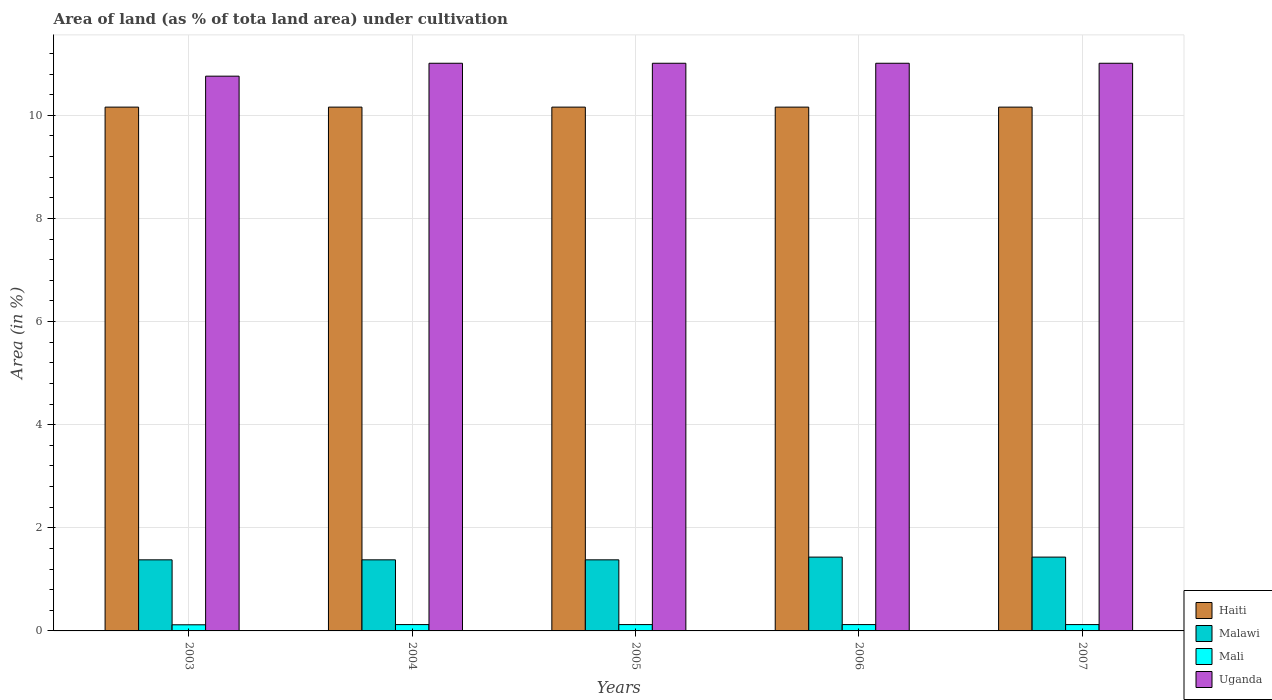Are the number of bars per tick equal to the number of legend labels?
Provide a short and direct response. Yes. How many bars are there on the 3rd tick from the left?
Offer a very short reply. 4. How many bars are there on the 5th tick from the right?
Offer a very short reply. 4. In how many cases, is the number of bars for a given year not equal to the number of legend labels?
Provide a succinct answer. 0. What is the percentage of land under cultivation in Malawi in 2005?
Give a very brief answer. 1.38. Across all years, what is the maximum percentage of land under cultivation in Uganda?
Your answer should be very brief. 11.01. Across all years, what is the minimum percentage of land under cultivation in Uganda?
Keep it short and to the point. 10.76. What is the total percentage of land under cultivation in Malawi in the graph?
Your answer should be compact. 7. What is the difference between the percentage of land under cultivation in Malawi in 2004 and that in 2007?
Keep it short and to the point. -0.05. What is the difference between the percentage of land under cultivation in Uganda in 2006 and the percentage of land under cultivation in Mali in 2004?
Offer a terse response. 10.89. What is the average percentage of land under cultivation in Mali per year?
Ensure brevity in your answer.  0.12. In the year 2004, what is the difference between the percentage of land under cultivation in Mali and percentage of land under cultivation in Haiti?
Your response must be concise. -10.04. In how many years, is the percentage of land under cultivation in Mali greater than 4.4 %?
Your answer should be compact. 0. What is the difference between the highest and the lowest percentage of land under cultivation in Uganda?
Keep it short and to the point. 0.25. What does the 1st bar from the left in 2004 represents?
Your response must be concise. Haiti. What does the 4th bar from the right in 2006 represents?
Your answer should be very brief. Haiti. Is it the case that in every year, the sum of the percentage of land under cultivation in Mali and percentage of land under cultivation in Haiti is greater than the percentage of land under cultivation in Malawi?
Your answer should be compact. Yes. How many bars are there?
Provide a succinct answer. 20. Are all the bars in the graph horizontal?
Your response must be concise. No. Are the values on the major ticks of Y-axis written in scientific E-notation?
Make the answer very short. No. How many legend labels are there?
Provide a short and direct response. 4. How are the legend labels stacked?
Make the answer very short. Vertical. What is the title of the graph?
Your answer should be compact. Area of land (as % of tota land area) under cultivation. Does "Trinidad and Tobago" appear as one of the legend labels in the graph?
Give a very brief answer. No. What is the label or title of the X-axis?
Provide a succinct answer. Years. What is the label or title of the Y-axis?
Keep it short and to the point. Area (in %). What is the Area (in %) in Haiti in 2003?
Provide a succinct answer. 10.16. What is the Area (in %) of Malawi in 2003?
Keep it short and to the point. 1.38. What is the Area (in %) in Mali in 2003?
Provide a short and direct response. 0.12. What is the Area (in %) in Uganda in 2003?
Provide a succinct answer. 10.76. What is the Area (in %) in Haiti in 2004?
Offer a very short reply. 10.16. What is the Area (in %) of Malawi in 2004?
Provide a short and direct response. 1.38. What is the Area (in %) of Mali in 2004?
Ensure brevity in your answer.  0.12. What is the Area (in %) in Uganda in 2004?
Keep it short and to the point. 11.01. What is the Area (in %) of Haiti in 2005?
Offer a very short reply. 10.16. What is the Area (in %) of Malawi in 2005?
Keep it short and to the point. 1.38. What is the Area (in %) of Mali in 2005?
Offer a very short reply. 0.12. What is the Area (in %) of Uganda in 2005?
Ensure brevity in your answer.  11.01. What is the Area (in %) in Haiti in 2006?
Give a very brief answer. 10.16. What is the Area (in %) of Malawi in 2006?
Your response must be concise. 1.43. What is the Area (in %) in Mali in 2006?
Provide a succinct answer. 0.12. What is the Area (in %) of Uganda in 2006?
Your answer should be very brief. 11.01. What is the Area (in %) of Haiti in 2007?
Your answer should be very brief. 10.16. What is the Area (in %) of Malawi in 2007?
Offer a very short reply. 1.43. What is the Area (in %) in Mali in 2007?
Offer a very short reply. 0.12. What is the Area (in %) of Uganda in 2007?
Your answer should be very brief. 11.01. Across all years, what is the maximum Area (in %) in Haiti?
Provide a short and direct response. 10.16. Across all years, what is the maximum Area (in %) of Malawi?
Your answer should be very brief. 1.43. Across all years, what is the maximum Area (in %) in Mali?
Give a very brief answer. 0.12. Across all years, what is the maximum Area (in %) in Uganda?
Provide a succinct answer. 11.01. Across all years, what is the minimum Area (in %) in Haiti?
Give a very brief answer. 10.16. Across all years, what is the minimum Area (in %) in Malawi?
Keep it short and to the point. 1.38. Across all years, what is the minimum Area (in %) in Mali?
Your answer should be very brief. 0.12. Across all years, what is the minimum Area (in %) of Uganda?
Offer a very short reply. 10.76. What is the total Area (in %) of Haiti in the graph?
Provide a succinct answer. 50.8. What is the total Area (in %) in Malawi in the graph?
Offer a terse response. 7. What is the total Area (in %) of Mali in the graph?
Keep it short and to the point. 0.61. What is the total Area (in %) in Uganda in the graph?
Provide a short and direct response. 54.8. What is the difference between the Area (in %) of Malawi in 2003 and that in 2004?
Offer a very short reply. 0. What is the difference between the Area (in %) of Mali in 2003 and that in 2004?
Your answer should be compact. -0. What is the difference between the Area (in %) in Uganda in 2003 and that in 2004?
Give a very brief answer. -0.25. What is the difference between the Area (in %) in Mali in 2003 and that in 2005?
Your answer should be very brief. -0. What is the difference between the Area (in %) of Uganda in 2003 and that in 2005?
Your answer should be very brief. -0.25. What is the difference between the Area (in %) in Malawi in 2003 and that in 2006?
Keep it short and to the point. -0.05. What is the difference between the Area (in %) in Mali in 2003 and that in 2006?
Offer a terse response. -0. What is the difference between the Area (in %) in Uganda in 2003 and that in 2006?
Offer a terse response. -0.25. What is the difference between the Area (in %) in Malawi in 2003 and that in 2007?
Your response must be concise. -0.05. What is the difference between the Area (in %) in Mali in 2003 and that in 2007?
Make the answer very short. -0. What is the difference between the Area (in %) in Uganda in 2003 and that in 2007?
Provide a succinct answer. -0.25. What is the difference between the Area (in %) of Haiti in 2004 and that in 2005?
Give a very brief answer. 0. What is the difference between the Area (in %) in Uganda in 2004 and that in 2005?
Give a very brief answer. 0. What is the difference between the Area (in %) of Malawi in 2004 and that in 2006?
Your answer should be very brief. -0.05. What is the difference between the Area (in %) in Mali in 2004 and that in 2006?
Your answer should be very brief. 0. What is the difference between the Area (in %) of Uganda in 2004 and that in 2006?
Provide a succinct answer. 0. What is the difference between the Area (in %) of Haiti in 2004 and that in 2007?
Your answer should be compact. 0. What is the difference between the Area (in %) of Malawi in 2004 and that in 2007?
Your answer should be very brief. -0.05. What is the difference between the Area (in %) of Haiti in 2005 and that in 2006?
Ensure brevity in your answer.  0. What is the difference between the Area (in %) in Malawi in 2005 and that in 2006?
Ensure brevity in your answer.  -0.05. What is the difference between the Area (in %) in Mali in 2005 and that in 2006?
Provide a short and direct response. 0. What is the difference between the Area (in %) in Haiti in 2005 and that in 2007?
Your response must be concise. 0. What is the difference between the Area (in %) of Malawi in 2005 and that in 2007?
Give a very brief answer. -0.05. What is the difference between the Area (in %) in Mali in 2005 and that in 2007?
Give a very brief answer. 0. What is the difference between the Area (in %) in Haiti in 2006 and that in 2007?
Ensure brevity in your answer.  0. What is the difference between the Area (in %) in Mali in 2006 and that in 2007?
Your answer should be very brief. 0. What is the difference between the Area (in %) in Uganda in 2006 and that in 2007?
Provide a succinct answer. 0. What is the difference between the Area (in %) in Haiti in 2003 and the Area (in %) in Malawi in 2004?
Your response must be concise. 8.78. What is the difference between the Area (in %) of Haiti in 2003 and the Area (in %) of Mali in 2004?
Your response must be concise. 10.04. What is the difference between the Area (in %) in Haiti in 2003 and the Area (in %) in Uganda in 2004?
Your answer should be compact. -0.85. What is the difference between the Area (in %) in Malawi in 2003 and the Area (in %) in Mali in 2004?
Your answer should be compact. 1.26. What is the difference between the Area (in %) in Malawi in 2003 and the Area (in %) in Uganda in 2004?
Ensure brevity in your answer.  -9.63. What is the difference between the Area (in %) in Mali in 2003 and the Area (in %) in Uganda in 2004?
Provide a succinct answer. -10.89. What is the difference between the Area (in %) in Haiti in 2003 and the Area (in %) in Malawi in 2005?
Offer a terse response. 8.78. What is the difference between the Area (in %) of Haiti in 2003 and the Area (in %) of Mali in 2005?
Your response must be concise. 10.04. What is the difference between the Area (in %) of Haiti in 2003 and the Area (in %) of Uganda in 2005?
Provide a succinct answer. -0.85. What is the difference between the Area (in %) of Malawi in 2003 and the Area (in %) of Mali in 2005?
Your answer should be very brief. 1.26. What is the difference between the Area (in %) in Malawi in 2003 and the Area (in %) in Uganda in 2005?
Provide a short and direct response. -9.63. What is the difference between the Area (in %) in Mali in 2003 and the Area (in %) in Uganda in 2005?
Provide a short and direct response. -10.89. What is the difference between the Area (in %) in Haiti in 2003 and the Area (in %) in Malawi in 2006?
Ensure brevity in your answer.  8.73. What is the difference between the Area (in %) of Haiti in 2003 and the Area (in %) of Mali in 2006?
Keep it short and to the point. 10.04. What is the difference between the Area (in %) of Haiti in 2003 and the Area (in %) of Uganda in 2006?
Make the answer very short. -0.85. What is the difference between the Area (in %) in Malawi in 2003 and the Area (in %) in Mali in 2006?
Provide a short and direct response. 1.26. What is the difference between the Area (in %) in Malawi in 2003 and the Area (in %) in Uganda in 2006?
Your answer should be compact. -9.63. What is the difference between the Area (in %) of Mali in 2003 and the Area (in %) of Uganda in 2006?
Offer a terse response. -10.89. What is the difference between the Area (in %) of Haiti in 2003 and the Area (in %) of Malawi in 2007?
Your answer should be compact. 8.73. What is the difference between the Area (in %) in Haiti in 2003 and the Area (in %) in Mali in 2007?
Provide a short and direct response. 10.04. What is the difference between the Area (in %) in Haiti in 2003 and the Area (in %) in Uganda in 2007?
Ensure brevity in your answer.  -0.85. What is the difference between the Area (in %) of Malawi in 2003 and the Area (in %) of Mali in 2007?
Give a very brief answer. 1.26. What is the difference between the Area (in %) of Malawi in 2003 and the Area (in %) of Uganda in 2007?
Your response must be concise. -9.63. What is the difference between the Area (in %) of Mali in 2003 and the Area (in %) of Uganda in 2007?
Provide a short and direct response. -10.89. What is the difference between the Area (in %) in Haiti in 2004 and the Area (in %) in Malawi in 2005?
Make the answer very short. 8.78. What is the difference between the Area (in %) of Haiti in 2004 and the Area (in %) of Mali in 2005?
Provide a succinct answer. 10.04. What is the difference between the Area (in %) in Haiti in 2004 and the Area (in %) in Uganda in 2005?
Ensure brevity in your answer.  -0.85. What is the difference between the Area (in %) of Malawi in 2004 and the Area (in %) of Mali in 2005?
Your answer should be very brief. 1.26. What is the difference between the Area (in %) of Malawi in 2004 and the Area (in %) of Uganda in 2005?
Keep it short and to the point. -9.63. What is the difference between the Area (in %) in Mali in 2004 and the Area (in %) in Uganda in 2005?
Offer a terse response. -10.89. What is the difference between the Area (in %) in Haiti in 2004 and the Area (in %) in Malawi in 2006?
Offer a terse response. 8.73. What is the difference between the Area (in %) in Haiti in 2004 and the Area (in %) in Mali in 2006?
Ensure brevity in your answer.  10.04. What is the difference between the Area (in %) of Haiti in 2004 and the Area (in %) of Uganda in 2006?
Your response must be concise. -0.85. What is the difference between the Area (in %) in Malawi in 2004 and the Area (in %) in Mali in 2006?
Offer a very short reply. 1.26. What is the difference between the Area (in %) of Malawi in 2004 and the Area (in %) of Uganda in 2006?
Make the answer very short. -9.63. What is the difference between the Area (in %) of Mali in 2004 and the Area (in %) of Uganda in 2006?
Give a very brief answer. -10.89. What is the difference between the Area (in %) in Haiti in 2004 and the Area (in %) in Malawi in 2007?
Give a very brief answer. 8.73. What is the difference between the Area (in %) in Haiti in 2004 and the Area (in %) in Mali in 2007?
Offer a very short reply. 10.04. What is the difference between the Area (in %) in Haiti in 2004 and the Area (in %) in Uganda in 2007?
Ensure brevity in your answer.  -0.85. What is the difference between the Area (in %) in Malawi in 2004 and the Area (in %) in Mali in 2007?
Offer a very short reply. 1.26. What is the difference between the Area (in %) of Malawi in 2004 and the Area (in %) of Uganda in 2007?
Keep it short and to the point. -9.63. What is the difference between the Area (in %) of Mali in 2004 and the Area (in %) of Uganda in 2007?
Make the answer very short. -10.89. What is the difference between the Area (in %) in Haiti in 2005 and the Area (in %) in Malawi in 2006?
Your response must be concise. 8.73. What is the difference between the Area (in %) in Haiti in 2005 and the Area (in %) in Mali in 2006?
Provide a succinct answer. 10.04. What is the difference between the Area (in %) of Haiti in 2005 and the Area (in %) of Uganda in 2006?
Offer a very short reply. -0.85. What is the difference between the Area (in %) in Malawi in 2005 and the Area (in %) in Mali in 2006?
Make the answer very short. 1.26. What is the difference between the Area (in %) in Malawi in 2005 and the Area (in %) in Uganda in 2006?
Offer a very short reply. -9.63. What is the difference between the Area (in %) of Mali in 2005 and the Area (in %) of Uganda in 2006?
Keep it short and to the point. -10.89. What is the difference between the Area (in %) of Haiti in 2005 and the Area (in %) of Malawi in 2007?
Offer a terse response. 8.73. What is the difference between the Area (in %) in Haiti in 2005 and the Area (in %) in Mali in 2007?
Provide a succinct answer. 10.04. What is the difference between the Area (in %) of Haiti in 2005 and the Area (in %) of Uganda in 2007?
Your answer should be compact. -0.85. What is the difference between the Area (in %) of Malawi in 2005 and the Area (in %) of Mali in 2007?
Give a very brief answer. 1.26. What is the difference between the Area (in %) of Malawi in 2005 and the Area (in %) of Uganda in 2007?
Your answer should be compact. -9.63. What is the difference between the Area (in %) in Mali in 2005 and the Area (in %) in Uganda in 2007?
Your answer should be very brief. -10.89. What is the difference between the Area (in %) in Haiti in 2006 and the Area (in %) in Malawi in 2007?
Offer a very short reply. 8.73. What is the difference between the Area (in %) of Haiti in 2006 and the Area (in %) of Mali in 2007?
Offer a terse response. 10.04. What is the difference between the Area (in %) of Haiti in 2006 and the Area (in %) of Uganda in 2007?
Provide a succinct answer. -0.85. What is the difference between the Area (in %) of Malawi in 2006 and the Area (in %) of Mali in 2007?
Provide a short and direct response. 1.31. What is the difference between the Area (in %) of Malawi in 2006 and the Area (in %) of Uganda in 2007?
Offer a very short reply. -9.58. What is the difference between the Area (in %) of Mali in 2006 and the Area (in %) of Uganda in 2007?
Your answer should be very brief. -10.89. What is the average Area (in %) of Haiti per year?
Make the answer very short. 10.16. What is the average Area (in %) in Malawi per year?
Your answer should be very brief. 1.4. What is the average Area (in %) in Mali per year?
Make the answer very short. 0.12. What is the average Area (in %) in Uganda per year?
Offer a very short reply. 10.96. In the year 2003, what is the difference between the Area (in %) in Haiti and Area (in %) in Malawi?
Give a very brief answer. 8.78. In the year 2003, what is the difference between the Area (in %) in Haiti and Area (in %) in Mali?
Provide a succinct answer. 10.04. In the year 2003, what is the difference between the Area (in %) in Haiti and Area (in %) in Uganda?
Make the answer very short. -0.6. In the year 2003, what is the difference between the Area (in %) of Malawi and Area (in %) of Mali?
Offer a very short reply. 1.26. In the year 2003, what is the difference between the Area (in %) in Malawi and Area (in %) in Uganda?
Your answer should be very brief. -9.38. In the year 2003, what is the difference between the Area (in %) in Mali and Area (in %) in Uganda?
Provide a short and direct response. -10.64. In the year 2004, what is the difference between the Area (in %) in Haiti and Area (in %) in Malawi?
Provide a short and direct response. 8.78. In the year 2004, what is the difference between the Area (in %) in Haiti and Area (in %) in Mali?
Offer a terse response. 10.04. In the year 2004, what is the difference between the Area (in %) in Haiti and Area (in %) in Uganda?
Make the answer very short. -0.85. In the year 2004, what is the difference between the Area (in %) in Malawi and Area (in %) in Mali?
Your answer should be very brief. 1.26. In the year 2004, what is the difference between the Area (in %) in Malawi and Area (in %) in Uganda?
Your answer should be very brief. -9.63. In the year 2004, what is the difference between the Area (in %) of Mali and Area (in %) of Uganda?
Keep it short and to the point. -10.89. In the year 2005, what is the difference between the Area (in %) in Haiti and Area (in %) in Malawi?
Your response must be concise. 8.78. In the year 2005, what is the difference between the Area (in %) in Haiti and Area (in %) in Mali?
Your response must be concise. 10.04. In the year 2005, what is the difference between the Area (in %) in Haiti and Area (in %) in Uganda?
Your response must be concise. -0.85. In the year 2005, what is the difference between the Area (in %) in Malawi and Area (in %) in Mali?
Provide a short and direct response. 1.26. In the year 2005, what is the difference between the Area (in %) in Malawi and Area (in %) in Uganda?
Your response must be concise. -9.63. In the year 2005, what is the difference between the Area (in %) of Mali and Area (in %) of Uganda?
Provide a succinct answer. -10.89. In the year 2006, what is the difference between the Area (in %) in Haiti and Area (in %) in Malawi?
Keep it short and to the point. 8.73. In the year 2006, what is the difference between the Area (in %) in Haiti and Area (in %) in Mali?
Offer a terse response. 10.04. In the year 2006, what is the difference between the Area (in %) in Haiti and Area (in %) in Uganda?
Make the answer very short. -0.85. In the year 2006, what is the difference between the Area (in %) of Malawi and Area (in %) of Mali?
Offer a terse response. 1.31. In the year 2006, what is the difference between the Area (in %) of Malawi and Area (in %) of Uganda?
Ensure brevity in your answer.  -9.58. In the year 2006, what is the difference between the Area (in %) in Mali and Area (in %) in Uganda?
Provide a short and direct response. -10.89. In the year 2007, what is the difference between the Area (in %) in Haiti and Area (in %) in Malawi?
Give a very brief answer. 8.73. In the year 2007, what is the difference between the Area (in %) in Haiti and Area (in %) in Mali?
Offer a very short reply. 10.04. In the year 2007, what is the difference between the Area (in %) of Haiti and Area (in %) of Uganda?
Your response must be concise. -0.85. In the year 2007, what is the difference between the Area (in %) in Malawi and Area (in %) in Mali?
Provide a short and direct response. 1.31. In the year 2007, what is the difference between the Area (in %) of Malawi and Area (in %) of Uganda?
Give a very brief answer. -9.58. In the year 2007, what is the difference between the Area (in %) in Mali and Area (in %) in Uganda?
Make the answer very short. -10.89. What is the ratio of the Area (in %) in Mali in 2003 to that in 2004?
Your answer should be very brief. 0.97. What is the ratio of the Area (in %) of Uganda in 2003 to that in 2004?
Keep it short and to the point. 0.98. What is the ratio of the Area (in %) in Malawi in 2003 to that in 2005?
Your answer should be very brief. 1. What is the ratio of the Area (in %) in Mali in 2003 to that in 2005?
Your response must be concise. 0.97. What is the ratio of the Area (in %) in Uganda in 2003 to that in 2005?
Your answer should be very brief. 0.98. What is the ratio of the Area (in %) in Haiti in 2003 to that in 2006?
Ensure brevity in your answer.  1. What is the ratio of the Area (in %) of Malawi in 2003 to that in 2006?
Your answer should be compact. 0.96. What is the ratio of the Area (in %) of Mali in 2003 to that in 2006?
Your answer should be very brief. 0.97. What is the ratio of the Area (in %) of Uganda in 2003 to that in 2006?
Offer a terse response. 0.98. What is the ratio of the Area (in %) in Mali in 2003 to that in 2007?
Ensure brevity in your answer.  0.97. What is the ratio of the Area (in %) in Uganda in 2003 to that in 2007?
Provide a succinct answer. 0.98. What is the ratio of the Area (in %) of Haiti in 2004 to that in 2005?
Ensure brevity in your answer.  1. What is the ratio of the Area (in %) in Malawi in 2004 to that in 2005?
Offer a very short reply. 1. What is the ratio of the Area (in %) in Haiti in 2004 to that in 2007?
Ensure brevity in your answer.  1. What is the ratio of the Area (in %) of Malawi in 2004 to that in 2007?
Offer a very short reply. 0.96. What is the ratio of the Area (in %) in Mali in 2004 to that in 2007?
Your answer should be compact. 1. What is the ratio of the Area (in %) of Uganda in 2004 to that in 2007?
Your answer should be compact. 1. What is the ratio of the Area (in %) in Mali in 2005 to that in 2006?
Your response must be concise. 1. What is the ratio of the Area (in %) of Uganda in 2005 to that in 2006?
Give a very brief answer. 1. What is the ratio of the Area (in %) of Haiti in 2005 to that in 2007?
Ensure brevity in your answer.  1. What is the ratio of the Area (in %) in Malawi in 2005 to that in 2007?
Offer a terse response. 0.96. What is the ratio of the Area (in %) in Malawi in 2006 to that in 2007?
Provide a short and direct response. 1. What is the difference between the highest and the second highest Area (in %) of Haiti?
Your answer should be compact. 0. What is the difference between the highest and the second highest Area (in %) in Mali?
Your answer should be very brief. 0. What is the difference between the highest and the lowest Area (in %) of Malawi?
Offer a terse response. 0.05. What is the difference between the highest and the lowest Area (in %) of Mali?
Offer a very short reply. 0. What is the difference between the highest and the lowest Area (in %) of Uganda?
Give a very brief answer. 0.25. 